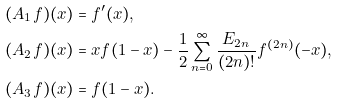<formula> <loc_0><loc_0><loc_500><loc_500>( A _ { 1 } f ) ( x ) & = f ^ { \prime } ( x ) , \\ ( A _ { 2 } f ) ( x ) & = x f ( 1 - x ) - \frac { 1 } { 2 } \sum _ { n = 0 } ^ { \infty } \frac { E _ { 2 n } } { ( 2 n ) ! } f ^ { ( 2 n ) } ( - x ) , \\ ( A _ { 3 } f ) ( x ) & = f ( 1 - x ) .</formula> 